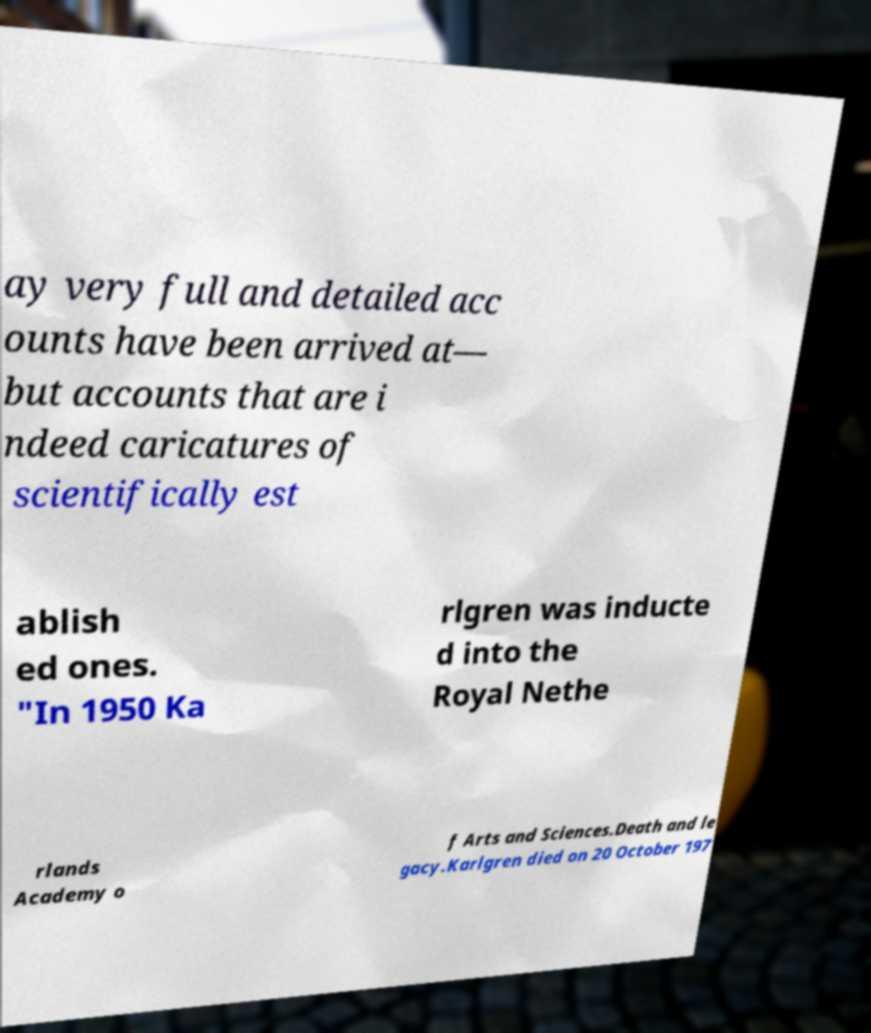What messages or text are displayed in this image? I need them in a readable, typed format. ay very full and detailed acc ounts have been arrived at— but accounts that are i ndeed caricatures of scientifically est ablish ed ones. "In 1950 Ka rlgren was inducte d into the Royal Nethe rlands Academy o f Arts and Sciences.Death and le gacy.Karlgren died on 20 October 197 